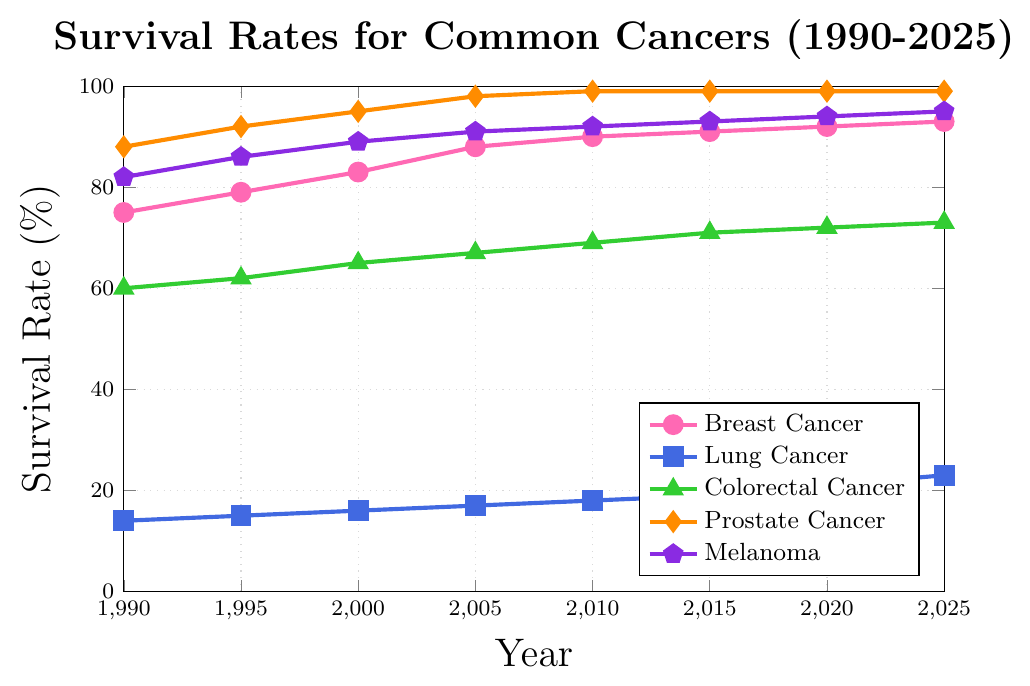What is the survival rate for Breast Cancer in the year 2000? Look at the Breast Cancer line (marked with circles) in the year 2000. The vertical position indicates the survival rate.
Answer: 83% Which cancer had the highest survival rate in the year 1990? Compare the vertical positions of all cancer survival rates in 1990. The highest line indicates the highest survival rate.
Answer: Prostate Cancer How did the survival rate for Lung Cancer change from 1990 to 2020? Look at the points on the Lung Cancer line (marked with squares) for the years 1990 and 2020. Subtract the 1990 rate from the 2020 rate.
Answer: Increased by 7% What is the average survival rate for Colorectal Cancer over the years 1990, 2000, and 2010? Add the survival rates for Colorectal Cancer in 1990, 2000, and 2010, then divide by the number of years. (60 + 65 + 69) / 3.
Answer: 64.67% Which cancer shows a consistent 99% survival rate from 2010 onwards? Identify the line that reaches and maintains a 99% survival rate from 2010 onwards.
Answer: Prostate Cancer Which year had the lowest survival rate for Melanoma, and what was it? Look for the lowest point on the Melanoma line (marked with pentagons) and identify the corresponding year and rate.
Answer: 1990, 82% Between which consecutive years did Breast Cancer survival rates see the highest increase? Examine the Breast Cancer line and compare the rate differences between consecutive years. The largest increase will be the highest difference.
Answer: 2000-2005 How many years did it take for Lung Cancer to increase from 14% to 18% survival rate? Look at the Lung Cancer survival rates for the years when it was 14% and 18%. Subtract the earlier year from the later year. (2010 - 1990)
Answer: 20 years Compare the changes in survival rates for Prostate Cancer and Melanoma from 1990 to 2020. Which one had a greater absolute increase? Look at the survival rates for Prostate Cancer and Melanoma in 1990 and 2020, calculate the differences, and compare them. (99 - 88) for Prostate Cancer and (94 - 82) for Melanoma.
Answer: Prostate Cancer had a greater increase What is the approximate difference between the survival rates for Breast Cancer and Lung Cancer in 2025? Find the survival rates for Breast Cancer and Lung Cancer in 2025, and subtract the smaller rate from the larger rate. (93 - 23)
Answer: 70% 